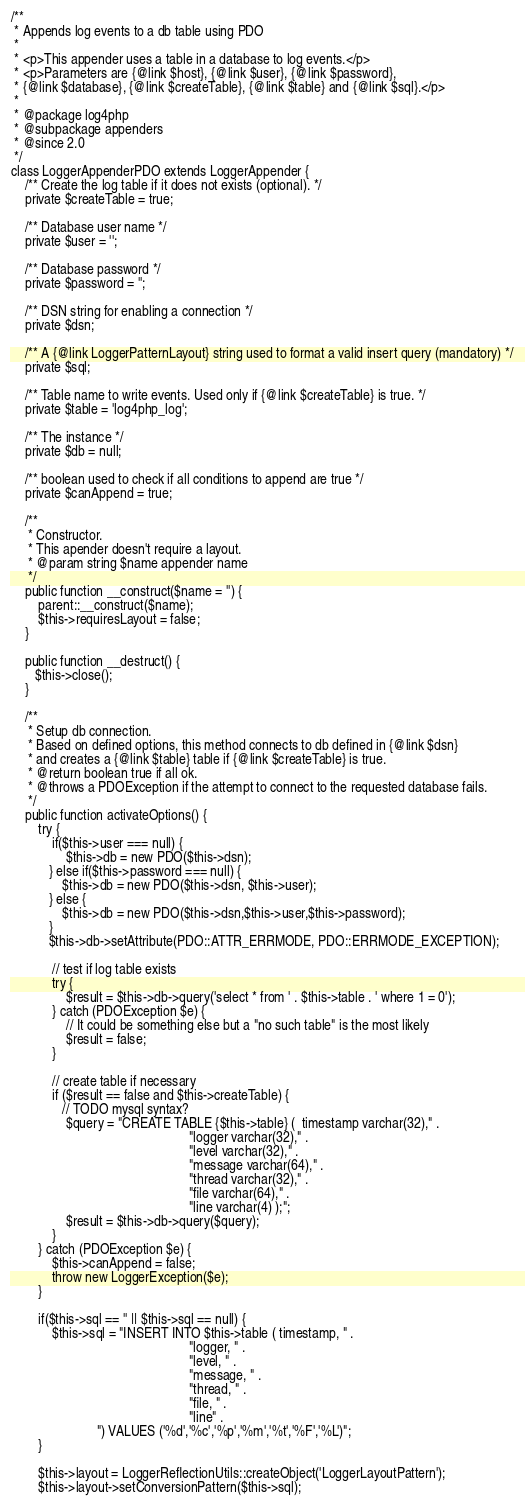<code> <loc_0><loc_0><loc_500><loc_500><_PHP_>
/**
 * Appends log events to a db table using PDO
 *
 * <p>This appender uses a table in a database to log events.</p>
 * <p>Parameters are {@link $host}, {@link $user}, {@link $password},
 * {@link $database}, {@link $createTable}, {@link $table} and {@link $sql}.</p>
 *
 * @package log4php
 * @subpackage appenders
 * @since 2.0
 */
class LoggerAppenderPDO extends LoggerAppender {
    /** Create the log table if it does not exists (optional). */
	private $createTable = true;
    
    /** Database user name */
    private $user = '';
    
    /** Database password */
    private $password = '';
    
	/** DSN string for enabling a connection */    
    private $dsn;
    
    /** A {@link LoggerPatternLayout} string used to format a valid insert query (mandatory) */
    private $sql;
    
    /** Table name to write events. Used only if {@link $createTable} is true. */    
    private $table = 'log4php_log';
    
    /** The instance */
    private $db = null;
    
    /** boolean used to check if all conditions to append are true */
    private $canAppend = true;
    
    /**
     * Constructor.
     * This apender doesn't require a layout.
     * @param string $name appender name
     */
    public function __construct($name = '') {
        parent::__construct($name);
        $this->requiresLayout = false;
    }
    
	public function __destruct() {
       $this->close();
   	}
   	
    /**
     * Setup db connection.
     * Based on defined options, this method connects to db defined in {@link $dsn}
     * and creates a {@link $table} table if {@link $createTable} is true.
     * @return boolean true if all ok.
     * @throws a PDOException if the attempt to connect to the requested database fails.
     */
    public function activateOptions() {
        try {
        	if($this->user === null) {
	           	$this->db = new PDO($this->dsn);
    	   } else if($this->password === null) {
    	       $this->db = new PDO($this->dsn, $this->user);
    	   } else {
    	       $this->db = new PDO($this->dsn,$this->user,$this->password);
    	   }
    	   $this->db->setAttribute(PDO::ATTR_ERRMODE, PDO::ERRMODE_EXCEPTION);
    	
            // test if log table exists
            try {
                $result = $this->db->query('select * from ' . $this->table . ' where 1 = 0');
            } catch (PDOException $e) {
                // It could be something else but a "no such table" is the most likely
                $result = false;
            }
            
            // create table if necessary
            if ($result == false and $this->createTable) {
        	   // TODO mysql syntax?
                $query = "CREATE TABLE {$this->table} (	 timestamp varchar(32)," .
            										"logger varchar(32)," .
            										"level varchar(32)," .
            										"message varchar(64)," .
            										"thread varchar(32)," .
            										"file varchar(64)," .
            										"line varchar(4) );";
                $result = $this->db->query($query);
            }
        } catch (PDOException $e) {
            $this->canAppend = false;
            throw new LoggerException($e);
        }
        
        if($this->sql == '' || $this->sql == null) {
            $this->sql = "INSERT INTO $this->table ( timestamp, " .
            										"logger, " .
            										"level, " .
            										"message, " .
            										"thread, " .
            										"file, " .
            										"line" .
						 ") VALUES ('%d','%c','%p','%m','%t','%F','%L')";
        }
        
		$this->layout = LoggerReflectionUtils::createObject('LoggerLayoutPattern');
        $this->layout->setConversionPattern($this->sql);</code> 